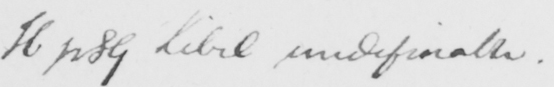Please provide the text content of this handwritten line. H p 89 Libel undefinable . 